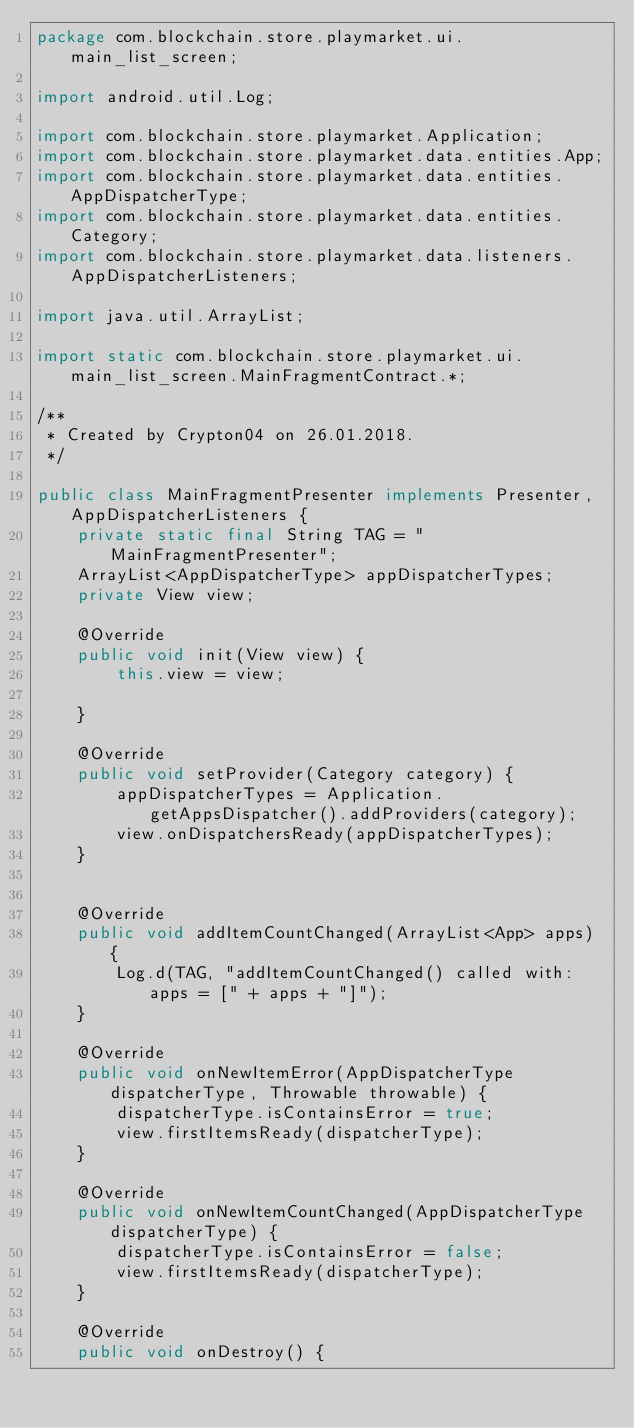<code> <loc_0><loc_0><loc_500><loc_500><_Java_>package com.blockchain.store.playmarket.ui.main_list_screen;

import android.util.Log;

import com.blockchain.store.playmarket.Application;
import com.blockchain.store.playmarket.data.entities.App;
import com.blockchain.store.playmarket.data.entities.AppDispatcherType;
import com.blockchain.store.playmarket.data.entities.Category;
import com.blockchain.store.playmarket.data.listeners.AppDispatcherListeners;

import java.util.ArrayList;

import static com.blockchain.store.playmarket.ui.main_list_screen.MainFragmentContract.*;

/**
 * Created by Crypton04 on 26.01.2018.
 */

public class MainFragmentPresenter implements Presenter, AppDispatcherListeners {
    private static final String TAG = "MainFragmentPresenter";
    ArrayList<AppDispatcherType> appDispatcherTypes;
    private View view;

    @Override
    public void init(View view) {
        this.view = view;

    }

    @Override
    public void setProvider(Category category) {
        appDispatcherTypes = Application.getAppsDispatcher().addProviders(category);
        view.onDispatchersReady(appDispatcherTypes);
    }


    @Override
    public void addItemCountChanged(ArrayList<App> apps) {
        Log.d(TAG, "addItemCountChanged() called with: apps = [" + apps + "]");
    }

    @Override
    public void onNewItemError(AppDispatcherType dispatcherType, Throwable throwable) {
        dispatcherType.isContainsError = true;
        view.firstItemsReady(dispatcherType);
    }

    @Override
    public void onNewItemCountChanged(AppDispatcherType dispatcherType) {
        dispatcherType.isContainsError = false;
        view.firstItemsReady(dispatcherType);
    }

    @Override
    public void onDestroy() {</code> 